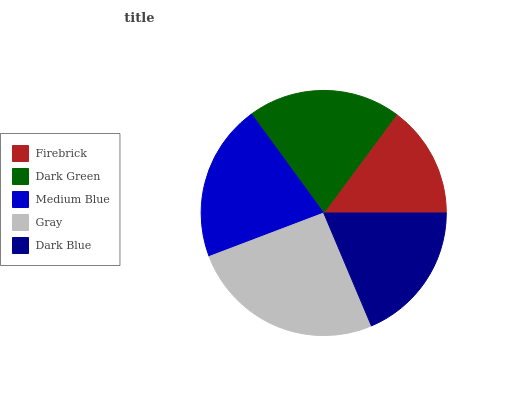Is Firebrick the minimum?
Answer yes or no. Yes. Is Gray the maximum?
Answer yes or no. Yes. Is Dark Green the minimum?
Answer yes or no. No. Is Dark Green the maximum?
Answer yes or no. No. Is Dark Green greater than Firebrick?
Answer yes or no. Yes. Is Firebrick less than Dark Green?
Answer yes or no. Yes. Is Firebrick greater than Dark Green?
Answer yes or no. No. Is Dark Green less than Firebrick?
Answer yes or no. No. Is Dark Green the high median?
Answer yes or no. Yes. Is Dark Green the low median?
Answer yes or no. Yes. Is Medium Blue the high median?
Answer yes or no. No. Is Gray the low median?
Answer yes or no. No. 